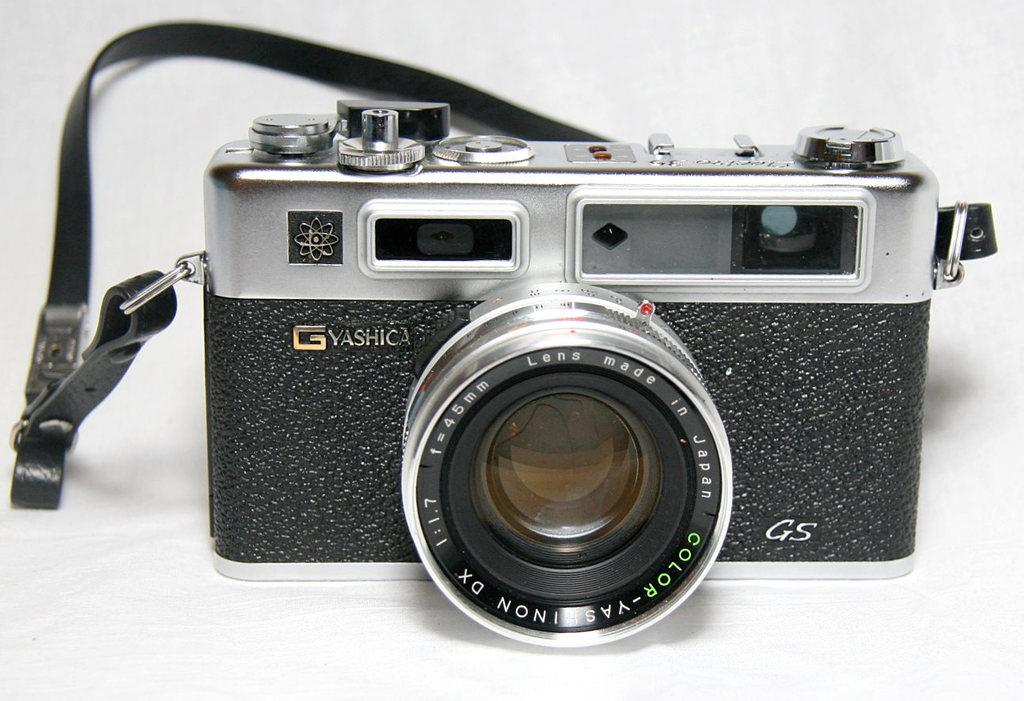What object is the main focus of the image? There is a camera in the image. Where is the camera located? The camera is present on a surface. What type of jelly is being used to hold the camera in place on the surface? There is no jelly present in the image, and the camera is not being held in place by any substance. 